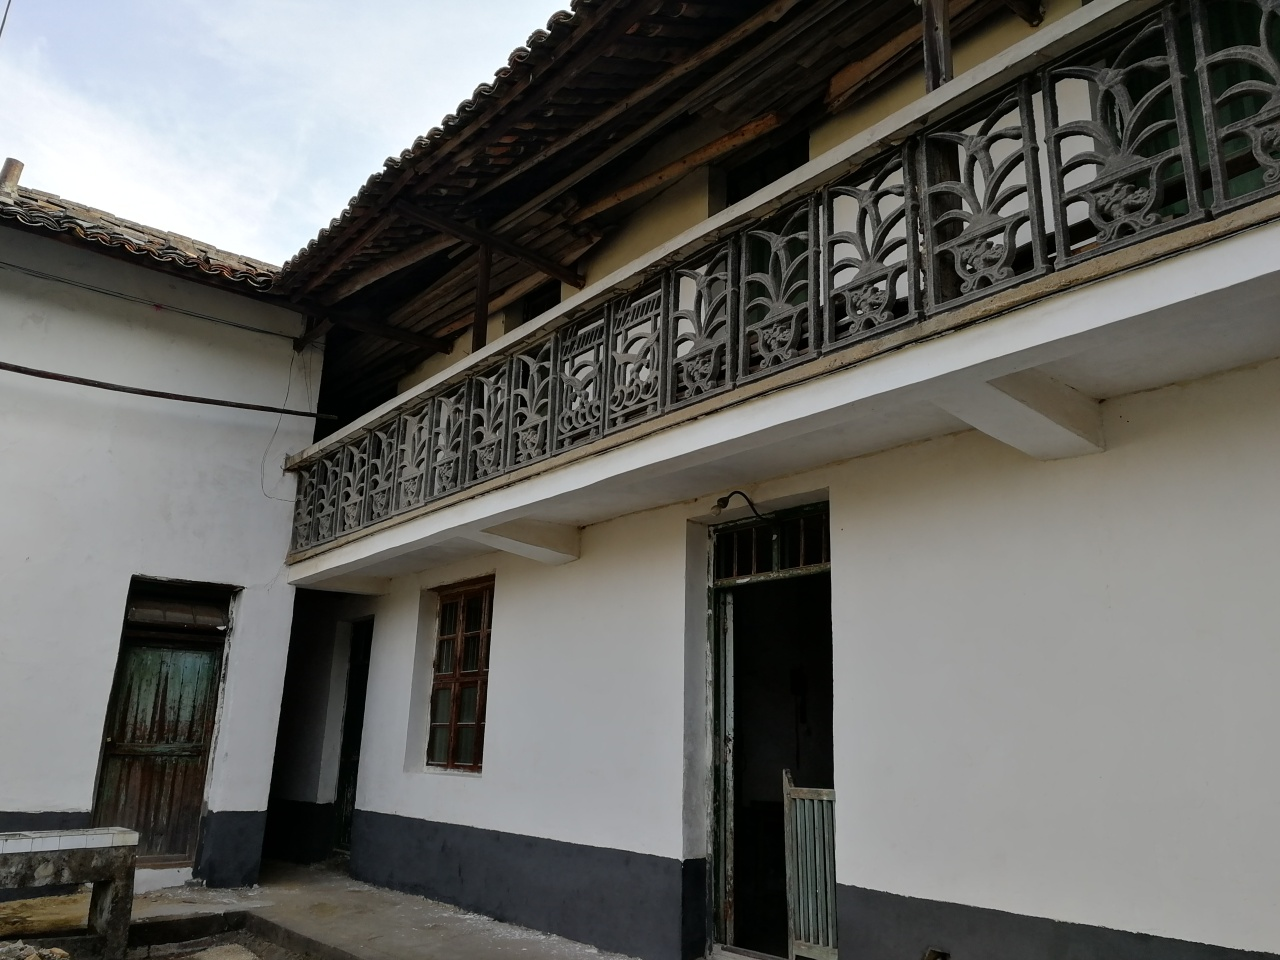What is the quality of this image?
A. Excellent
B. Very good
C. Average
Answer with the option's letter from the given choices directly. While the visual clarity of the image is reasonable, allowing for the identification of key elements like the balcony's intricate railing and the aged texture of the building, it lacks optimal lighting and image sharpness which could enhance its overall quality. Thus, the most fitting classification would be 'B. Very good', recognizing the balance between its strengths and areas for improvement. 